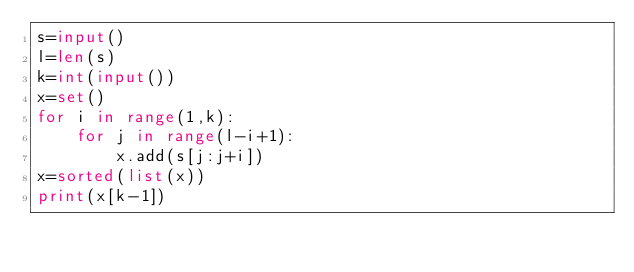<code> <loc_0><loc_0><loc_500><loc_500><_Python_>s=input()
l=len(s)
k=int(input())
x=set()
for i in range(1,k):
    for j in range(l-i+1):
        x.add(s[j:j+i])
x=sorted(list(x))
print(x[k-1])
</code> 